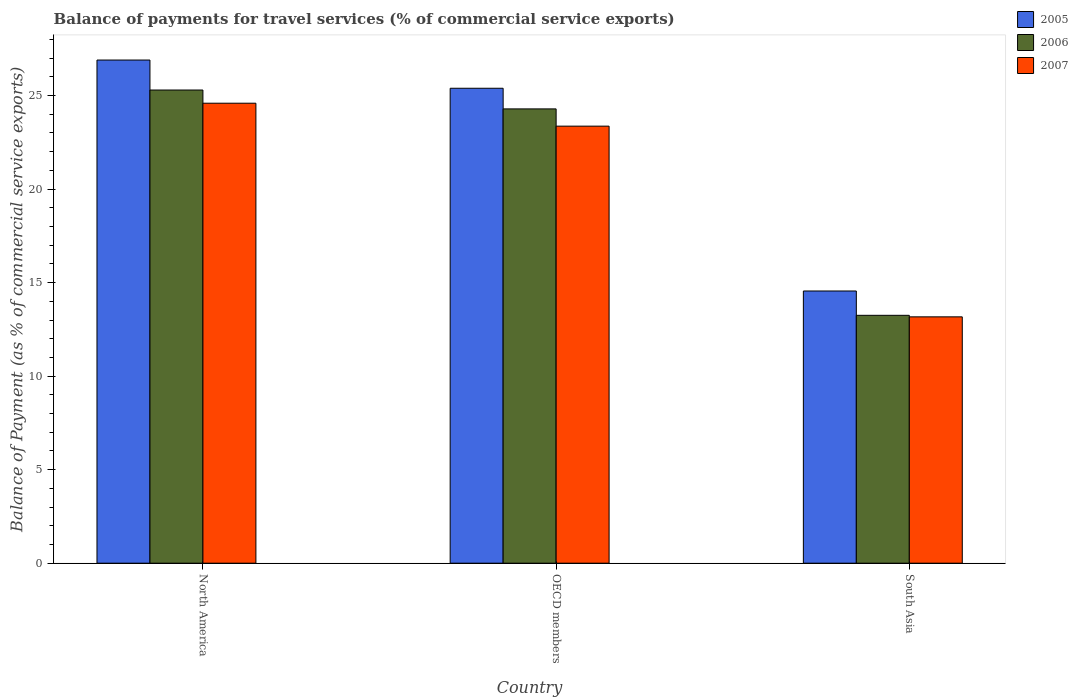How many groups of bars are there?
Make the answer very short. 3. Are the number of bars per tick equal to the number of legend labels?
Offer a terse response. Yes. Are the number of bars on each tick of the X-axis equal?
Keep it short and to the point. Yes. What is the balance of payments for travel services in 2005 in North America?
Your response must be concise. 26.9. Across all countries, what is the maximum balance of payments for travel services in 2005?
Your response must be concise. 26.9. Across all countries, what is the minimum balance of payments for travel services in 2007?
Provide a short and direct response. 13.17. In which country was the balance of payments for travel services in 2007 maximum?
Give a very brief answer. North America. What is the total balance of payments for travel services in 2005 in the graph?
Ensure brevity in your answer.  66.84. What is the difference between the balance of payments for travel services in 2005 in OECD members and that in South Asia?
Your answer should be compact. 10.84. What is the difference between the balance of payments for travel services in 2007 in OECD members and the balance of payments for travel services in 2006 in North America?
Provide a short and direct response. -1.93. What is the average balance of payments for travel services in 2007 per country?
Offer a very short reply. 20.38. What is the difference between the balance of payments for travel services of/in 2007 and balance of payments for travel services of/in 2005 in South Asia?
Make the answer very short. -1.38. In how many countries, is the balance of payments for travel services in 2005 greater than 4 %?
Your response must be concise. 3. What is the ratio of the balance of payments for travel services in 2005 in North America to that in OECD members?
Ensure brevity in your answer.  1.06. Is the balance of payments for travel services in 2007 in OECD members less than that in South Asia?
Give a very brief answer. No. What is the difference between the highest and the second highest balance of payments for travel services in 2007?
Make the answer very short. 11.42. What is the difference between the highest and the lowest balance of payments for travel services in 2005?
Make the answer very short. 12.35. Are the values on the major ticks of Y-axis written in scientific E-notation?
Offer a terse response. No. Does the graph contain grids?
Provide a succinct answer. No. How many legend labels are there?
Ensure brevity in your answer.  3. How are the legend labels stacked?
Ensure brevity in your answer.  Vertical. What is the title of the graph?
Your answer should be very brief. Balance of payments for travel services (% of commercial service exports). What is the label or title of the Y-axis?
Ensure brevity in your answer.  Balance of Payment (as % of commercial service exports). What is the Balance of Payment (as % of commercial service exports) in 2005 in North America?
Your response must be concise. 26.9. What is the Balance of Payment (as % of commercial service exports) in 2006 in North America?
Keep it short and to the point. 25.3. What is the Balance of Payment (as % of commercial service exports) in 2007 in North America?
Your response must be concise. 24.59. What is the Balance of Payment (as % of commercial service exports) in 2005 in OECD members?
Ensure brevity in your answer.  25.39. What is the Balance of Payment (as % of commercial service exports) in 2006 in OECD members?
Give a very brief answer. 24.29. What is the Balance of Payment (as % of commercial service exports) in 2007 in OECD members?
Your answer should be very brief. 23.36. What is the Balance of Payment (as % of commercial service exports) of 2005 in South Asia?
Your answer should be very brief. 14.55. What is the Balance of Payment (as % of commercial service exports) in 2006 in South Asia?
Your response must be concise. 13.25. What is the Balance of Payment (as % of commercial service exports) of 2007 in South Asia?
Ensure brevity in your answer.  13.17. Across all countries, what is the maximum Balance of Payment (as % of commercial service exports) in 2005?
Provide a succinct answer. 26.9. Across all countries, what is the maximum Balance of Payment (as % of commercial service exports) of 2006?
Provide a short and direct response. 25.3. Across all countries, what is the maximum Balance of Payment (as % of commercial service exports) of 2007?
Ensure brevity in your answer.  24.59. Across all countries, what is the minimum Balance of Payment (as % of commercial service exports) of 2005?
Make the answer very short. 14.55. Across all countries, what is the minimum Balance of Payment (as % of commercial service exports) of 2006?
Your response must be concise. 13.25. Across all countries, what is the minimum Balance of Payment (as % of commercial service exports) in 2007?
Provide a succinct answer. 13.17. What is the total Balance of Payment (as % of commercial service exports) of 2005 in the graph?
Provide a succinct answer. 66.84. What is the total Balance of Payment (as % of commercial service exports) in 2006 in the graph?
Offer a very short reply. 62.83. What is the total Balance of Payment (as % of commercial service exports) of 2007 in the graph?
Your response must be concise. 61.13. What is the difference between the Balance of Payment (as % of commercial service exports) of 2005 in North America and that in OECD members?
Provide a short and direct response. 1.51. What is the difference between the Balance of Payment (as % of commercial service exports) of 2006 in North America and that in OECD members?
Your response must be concise. 1.01. What is the difference between the Balance of Payment (as % of commercial service exports) in 2007 in North America and that in OECD members?
Make the answer very short. 1.23. What is the difference between the Balance of Payment (as % of commercial service exports) in 2005 in North America and that in South Asia?
Give a very brief answer. 12.35. What is the difference between the Balance of Payment (as % of commercial service exports) in 2006 in North America and that in South Asia?
Your response must be concise. 12.04. What is the difference between the Balance of Payment (as % of commercial service exports) of 2007 in North America and that in South Asia?
Offer a very short reply. 11.42. What is the difference between the Balance of Payment (as % of commercial service exports) in 2005 in OECD members and that in South Asia?
Your answer should be very brief. 10.84. What is the difference between the Balance of Payment (as % of commercial service exports) of 2006 in OECD members and that in South Asia?
Provide a succinct answer. 11.04. What is the difference between the Balance of Payment (as % of commercial service exports) of 2007 in OECD members and that in South Asia?
Ensure brevity in your answer.  10.2. What is the difference between the Balance of Payment (as % of commercial service exports) of 2005 in North America and the Balance of Payment (as % of commercial service exports) of 2006 in OECD members?
Offer a very short reply. 2.61. What is the difference between the Balance of Payment (as % of commercial service exports) of 2005 in North America and the Balance of Payment (as % of commercial service exports) of 2007 in OECD members?
Keep it short and to the point. 3.53. What is the difference between the Balance of Payment (as % of commercial service exports) of 2006 in North America and the Balance of Payment (as % of commercial service exports) of 2007 in OECD members?
Keep it short and to the point. 1.93. What is the difference between the Balance of Payment (as % of commercial service exports) of 2005 in North America and the Balance of Payment (as % of commercial service exports) of 2006 in South Asia?
Provide a succinct answer. 13.65. What is the difference between the Balance of Payment (as % of commercial service exports) in 2005 in North America and the Balance of Payment (as % of commercial service exports) in 2007 in South Asia?
Make the answer very short. 13.73. What is the difference between the Balance of Payment (as % of commercial service exports) of 2006 in North America and the Balance of Payment (as % of commercial service exports) of 2007 in South Asia?
Your response must be concise. 12.13. What is the difference between the Balance of Payment (as % of commercial service exports) in 2005 in OECD members and the Balance of Payment (as % of commercial service exports) in 2006 in South Asia?
Keep it short and to the point. 12.14. What is the difference between the Balance of Payment (as % of commercial service exports) in 2005 in OECD members and the Balance of Payment (as % of commercial service exports) in 2007 in South Asia?
Your answer should be compact. 12.22. What is the difference between the Balance of Payment (as % of commercial service exports) in 2006 in OECD members and the Balance of Payment (as % of commercial service exports) in 2007 in South Asia?
Keep it short and to the point. 11.12. What is the average Balance of Payment (as % of commercial service exports) in 2005 per country?
Make the answer very short. 22.28. What is the average Balance of Payment (as % of commercial service exports) of 2006 per country?
Your answer should be very brief. 20.94. What is the average Balance of Payment (as % of commercial service exports) of 2007 per country?
Offer a very short reply. 20.38. What is the difference between the Balance of Payment (as % of commercial service exports) in 2005 and Balance of Payment (as % of commercial service exports) in 2006 in North America?
Give a very brief answer. 1.6. What is the difference between the Balance of Payment (as % of commercial service exports) in 2005 and Balance of Payment (as % of commercial service exports) in 2007 in North America?
Give a very brief answer. 2.31. What is the difference between the Balance of Payment (as % of commercial service exports) in 2006 and Balance of Payment (as % of commercial service exports) in 2007 in North America?
Your answer should be very brief. 0.7. What is the difference between the Balance of Payment (as % of commercial service exports) of 2005 and Balance of Payment (as % of commercial service exports) of 2006 in OECD members?
Offer a terse response. 1.1. What is the difference between the Balance of Payment (as % of commercial service exports) of 2005 and Balance of Payment (as % of commercial service exports) of 2007 in OECD members?
Provide a succinct answer. 2.03. What is the difference between the Balance of Payment (as % of commercial service exports) of 2006 and Balance of Payment (as % of commercial service exports) of 2007 in OECD members?
Offer a very short reply. 0.92. What is the difference between the Balance of Payment (as % of commercial service exports) of 2005 and Balance of Payment (as % of commercial service exports) of 2006 in South Asia?
Provide a short and direct response. 1.3. What is the difference between the Balance of Payment (as % of commercial service exports) in 2005 and Balance of Payment (as % of commercial service exports) in 2007 in South Asia?
Your response must be concise. 1.38. What is the difference between the Balance of Payment (as % of commercial service exports) in 2006 and Balance of Payment (as % of commercial service exports) in 2007 in South Asia?
Offer a terse response. 0.08. What is the ratio of the Balance of Payment (as % of commercial service exports) of 2005 in North America to that in OECD members?
Provide a succinct answer. 1.06. What is the ratio of the Balance of Payment (as % of commercial service exports) of 2006 in North America to that in OECD members?
Offer a very short reply. 1.04. What is the ratio of the Balance of Payment (as % of commercial service exports) in 2007 in North America to that in OECD members?
Provide a short and direct response. 1.05. What is the ratio of the Balance of Payment (as % of commercial service exports) in 2005 in North America to that in South Asia?
Provide a short and direct response. 1.85. What is the ratio of the Balance of Payment (as % of commercial service exports) in 2006 in North America to that in South Asia?
Offer a terse response. 1.91. What is the ratio of the Balance of Payment (as % of commercial service exports) of 2007 in North America to that in South Asia?
Provide a succinct answer. 1.87. What is the ratio of the Balance of Payment (as % of commercial service exports) in 2005 in OECD members to that in South Asia?
Provide a succinct answer. 1.74. What is the ratio of the Balance of Payment (as % of commercial service exports) in 2006 in OECD members to that in South Asia?
Offer a terse response. 1.83. What is the ratio of the Balance of Payment (as % of commercial service exports) of 2007 in OECD members to that in South Asia?
Your response must be concise. 1.77. What is the difference between the highest and the second highest Balance of Payment (as % of commercial service exports) in 2005?
Your response must be concise. 1.51. What is the difference between the highest and the second highest Balance of Payment (as % of commercial service exports) in 2006?
Provide a short and direct response. 1.01. What is the difference between the highest and the second highest Balance of Payment (as % of commercial service exports) in 2007?
Your answer should be compact. 1.23. What is the difference between the highest and the lowest Balance of Payment (as % of commercial service exports) in 2005?
Your answer should be compact. 12.35. What is the difference between the highest and the lowest Balance of Payment (as % of commercial service exports) of 2006?
Give a very brief answer. 12.04. What is the difference between the highest and the lowest Balance of Payment (as % of commercial service exports) of 2007?
Your answer should be very brief. 11.42. 